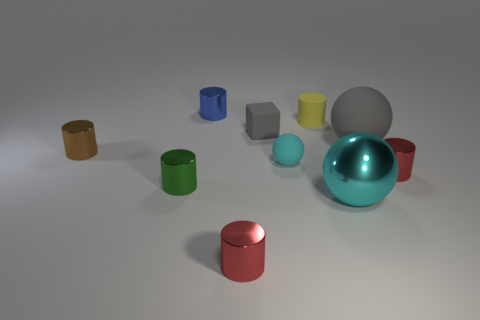What number of cubes have the same material as the tiny cyan thing?
Your answer should be very brief. 1. Is the number of cyan rubber objects less than the number of small red cylinders?
Provide a short and direct response. Yes. There is a big object in front of the tiny cyan thing; is its color the same as the tiny ball?
Your answer should be very brief. Yes. There is a cyan rubber ball behind the cylinder on the right side of the large gray matte ball; how many spheres are behind it?
Provide a succinct answer. 1. What number of gray things are behind the big gray rubber ball?
Offer a very short reply. 1. There is another tiny rubber object that is the same shape as the tiny blue thing; what is its color?
Your response must be concise. Yellow. What is the material of the tiny cylinder that is to the left of the cyan matte object and on the right side of the small blue metal object?
Your response must be concise. Metal. Is the size of the matte ball in front of the brown cylinder the same as the large gray thing?
Ensure brevity in your answer.  No. What is the small gray thing made of?
Ensure brevity in your answer.  Rubber. There is a tiny thing that is in front of the green metallic thing; what is its color?
Make the answer very short. Red. 